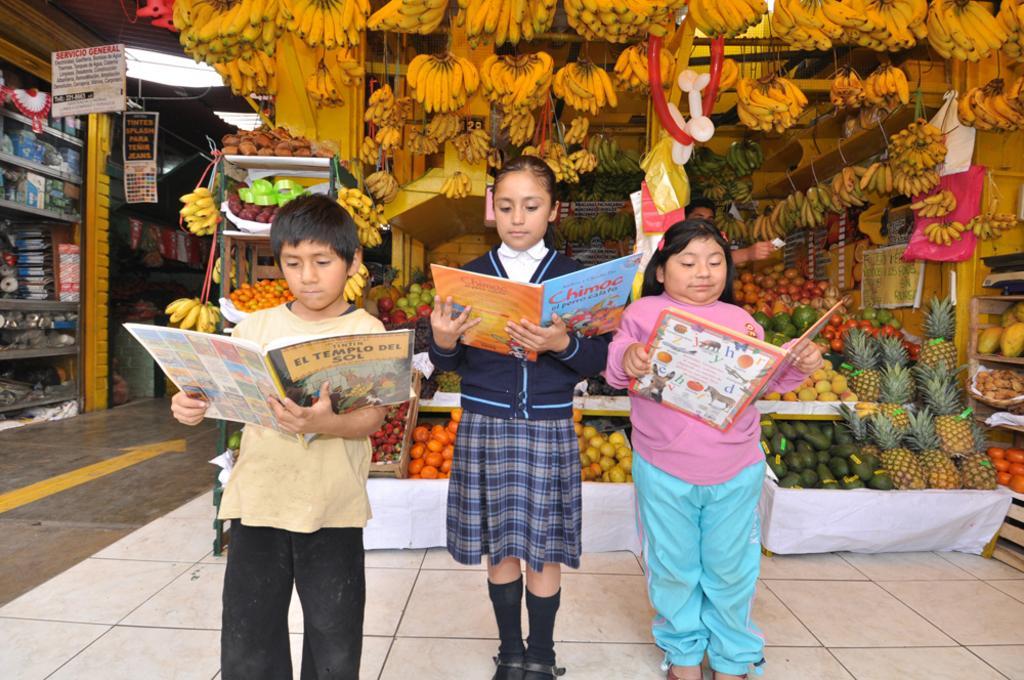Can you describe this image briefly? In this picture, we can see there are three kids standing on the floor and holding books. Behind the kids there are different kinds of fruits and other things. On the left side of the people there are shops. 